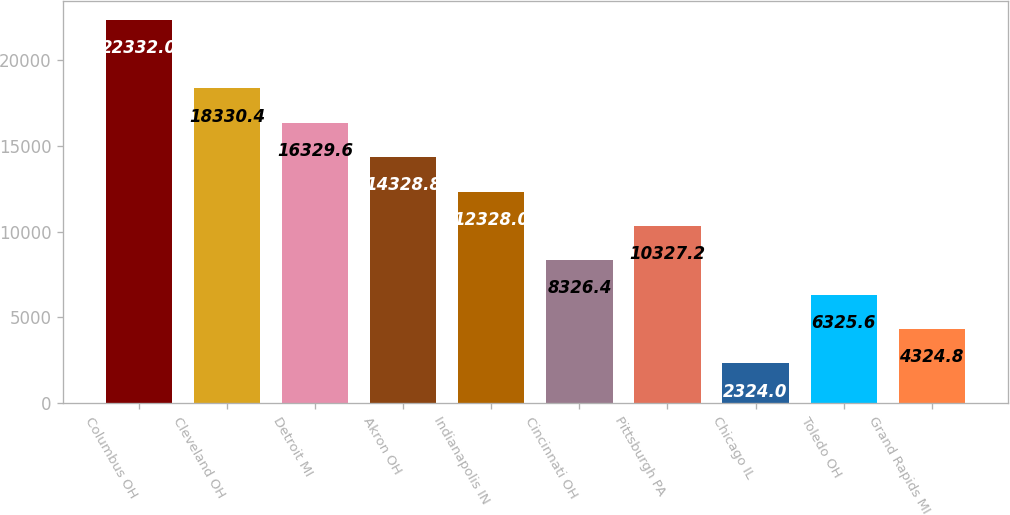Convert chart. <chart><loc_0><loc_0><loc_500><loc_500><bar_chart><fcel>Columbus OH<fcel>Cleveland OH<fcel>Detroit MI<fcel>Akron OH<fcel>Indianapolis IN<fcel>Cincinnati OH<fcel>Pittsburgh PA<fcel>Chicago IL<fcel>Toledo OH<fcel>Grand Rapids MI<nl><fcel>22332<fcel>18330.4<fcel>16329.6<fcel>14328.8<fcel>12328<fcel>8326.4<fcel>10327.2<fcel>2324<fcel>6325.6<fcel>4324.8<nl></chart> 